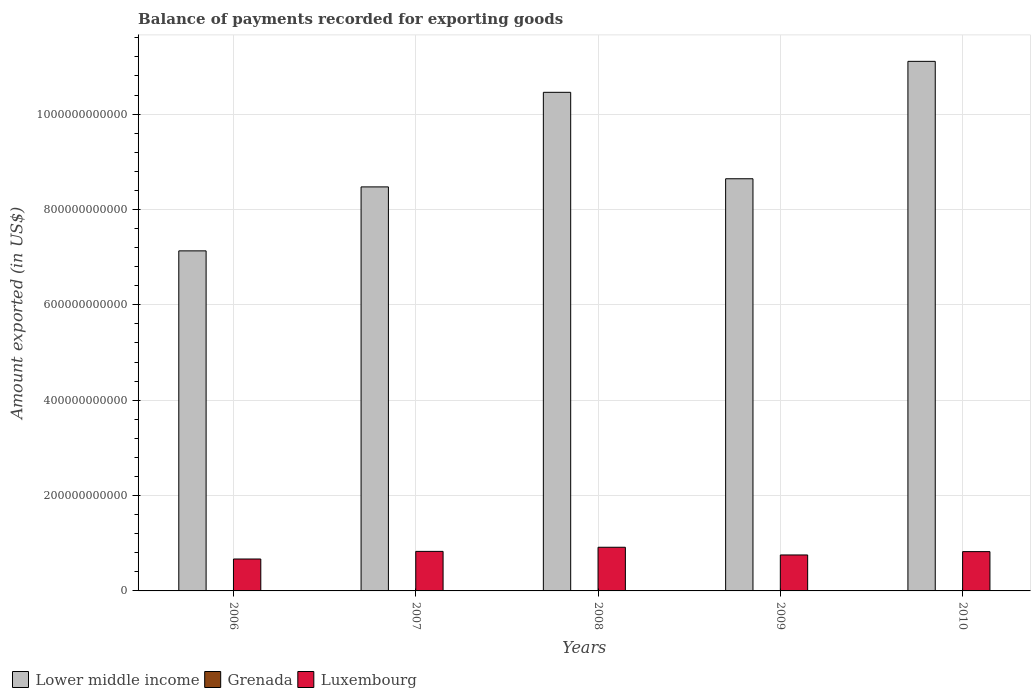How many different coloured bars are there?
Give a very brief answer. 3. How many groups of bars are there?
Make the answer very short. 5. Are the number of bars on each tick of the X-axis equal?
Provide a short and direct response. Yes. How many bars are there on the 4th tick from the right?
Your answer should be very brief. 3. What is the label of the 5th group of bars from the left?
Ensure brevity in your answer.  2010. What is the amount exported in Luxembourg in 2008?
Your answer should be very brief. 9.16e+1. Across all years, what is the maximum amount exported in Luxembourg?
Offer a very short reply. 9.16e+1. Across all years, what is the minimum amount exported in Lower middle income?
Provide a succinct answer. 7.13e+11. In which year was the amount exported in Luxembourg maximum?
Your response must be concise. 2008. In which year was the amount exported in Lower middle income minimum?
Make the answer very short. 2006. What is the total amount exported in Lower middle income in the graph?
Keep it short and to the point. 4.58e+12. What is the difference between the amount exported in Grenada in 2006 and that in 2007?
Your answer should be very brief. -4.72e+07. What is the difference between the amount exported in Luxembourg in 2008 and the amount exported in Lower middle income in 2010?
Your answer should be very brief. -1.02e+12. What is the average amount exported in Lower middle income per year?
Your answer should be very brief. 9.16e+11. In the year 2008, what is the difference between the amount exported in Lower middle income and amount exported in Luxembourg?
Keep it short and to the point. 9.54e+11. What is the ratio of the amount exported in Lower middle income in 2007 to that in 2010?
Ensure brevity in your answer.  0.76. What is the difference between the highest and the second highest amount exported in Grenada?
Your answer should be very brief. 1.75e+06. What is the difference between the highest and the lowest amount exported in Luxembourg?
Your answer should be very brief. 2.47e+1. Is the sum of the amount exported in Lower middle income in 2008 and 2009 greater than the maximum amount exported in Grenada across all years?
Provide a succinct answer. Yes. What does the 1st bar from the left in 2008 represents?
Provide a succinct answer. Lower middle income. What does the 2nd bar from the right in 2009 represents?
Provide a short and direct response. Grenada. Is it the case that in every year, the sum of the amount exported in Luxembourg and amount exported in Lower middle income is greater than the amount exported in Grenada?
Ensure brevity in your answer.  Yes. Are all the bars in the graph horizontal?
Provide a short and direct response. No. How many years are there in the graph?
Give a very brief answer. 5. What is the difference between two consecutive major ticks on the Y-axis?
Make the answer very short. 2.00e+11. Does the graph contain grids?
Make the answer very short. Yes. What is the title of the graph?
Your answer should be very brief. Balance of payments recorded for exporting goods. Does "Kiribati" appear as one of the legend labels in the graph?
Make the answer very short. No. What is the label or title of the X-axis?
Offer a very short reply. Years. What is the label or title of the Y-axis?
Your answer should be compact. Amount exported (in US$). What is the Amount exported (in US$) of Lower middle income in 2006?
Your answer should be compact. 7.13e+11. What is the Amount exported (in US$) of Grenada in 2006?
Your answer should be very brief. 1.62e+08. What is the Amount exported (in US$) in Luxembourg in 2006?
Ensure brevity in your answer.  6.69e+1. What is the Amount exported (in US$) in Lower middle income in 2007?
Offer a terse response. 8.47e+11. What is the Amount exported (in US$) of Grenada in 2007?
Give a very brief answer. 2.10e+08. What is the Amount exported (in US$) in Luxembourg in 2007?
Your answer should be very brief. 8.29e+1. What is the Amount exported (in US$) of Lower middle income in 2008?
Provide a succinct answer. 1.05e+12. What is the Amount exported (in US$) of Grenada in 2008?
Your answer should be very brief. 2.08e+08. What is the Amount exported (in US$) in Luxembourg in 2008?
Provide a succinct answer. 9.16e+1. What is the Amount exported (in US$) of Lower middle income in 2009?
Provide a short and direct response. 8.64e+11. What is the Amount exported (in US$) of Grenada in 2009?
Provide a succinct answer. 1.87e+08. What is the Amount exported (in US$) of Luxembourg in 2009?
Provide a short and direct response. 7.54e+1. What is the Amount exported (in US$) in Lower middle income in 2010?
Ensure brevity in your answer.  1.11e+12. What is the Amount exported (in US$) of Grenada in 2010?
Provide a short and direct response. 1.84e+08. What is the Amount exported (in US$) in Luxembourg in 2010?
Offer a very short reply. 8.24e+1. Across all years, what is the maximum Amount exported (in US$) in Lower middle income?
Offer a very short reply. 1.11e+12. Across all years, what is the maximum Amount exported (in US$) of Grenada?
Provide a short and direct response. 2.10e+08. Across all years, what is the maximum Amount exported (in US$) in Luxembourg?
Offer a terse response. 9.16e+1. Across all years, what is the minimum Amount exported (in US$) in Lower middle income?
Your answer should be compact. 7.13e+11. Across all years, what is the minimum Amount exported (in US$) in Grenada?
Your response must be concise. 1.62e+08. Across all years, what is the minimum Amount exported (in US$) of Luxembourg?
Your response must be concise. 6.69e+1. What is the total Amount exported (in US$) in Lower middle income in the graph?
Keep it short and to the point. 4.58e+12. What is the total Amount exported (in US$) of Grenada in the graph?
Your response must be concise. 9.51e+08. What is the total Amount exported (in US$) in Luxembourg in the graph?
Offer a terse response. 3.99e+11. What is the difference between the Amount exported (in US$) in Lower middle income in 2006 and that in 2007?
Keep it short and to the point. -1.34e+11. What is the difference between the Amount exported (in US$) of Grenada in 2006 and that in 2007?
Offer a terse response. -4.72e+07. What is the difference between the Amount exported (in US$) in Luxembourg in 2006 and that in 2007?
Your answer should be compact. -1.60e+1. What is the difference between the Amount exported (in US$) of Lower middle income in 2006 and that in 2008?
Provide a succinct answer. -3.33e+11. What is the difference between the Amount exported (in US$) of Grenada in 2006 and that in 2008?
Provide a short and direct response. -4.55e+07. What is the difference between the Amount exported (in US$) in Luxembourg in 2006 and that in 2008?
Your response must be concise. -2.47e+1. What is the difference between the Amount exported (in US$) in Lower middle income in 2006 and that in 2009?
Provide a short and direct response. -1.51e+11. What is the difference between the Amount exported (in US$) of Grenada in 2006 and that in 2009?
Provide a succinct answer. -2.49e+07. What is the difference between the Amount exported (in US$) of Luxembourg in 2006 and that in 2009?
Make the answer very short. -8.52e+09. What is the difference between the Amount exported (in US$) in Lower middle income in 2006 and that in 2010?
Give a very brief answer. -3.97e+11. What is the difference between the Amount exported (in US$) of Grenada in 2006 and that in 2010?
Provide a succinct answer. -2.15e+07. What is the difference between the Amount exported (in US$) of Luxembourg in 2006 and that in 2010?
Give a very brief answer. -1.55e+1. What is the difference between the Amount exported (in US$) of Lower middle income in 2007 and that in 2008?
Keep it short and to the point. -1.98e+11. What is the difference between the Amount exported (in US$) in Grenada in 2007 and that in 2008?
Offer a terse response. 1.75e+06. What is the difference between the Amount exported (in US$) in Luxembourg in 2007 and that in 2008?
Ensure brevity in your answer.  -8.66e+09. What is the difference between the Amount exported (in US$) of Lower middle income in 2007 and that in 2009?
Your answer should be compact. -1.71e+1. What is the difference between the Amount exported (in US$) in Grenada in 2007 and that in 2009?
Your answer should be compact. 2.23e+07. What is the difference between the Amount exported (in US$) in Luxembourg in 2007 and that in 2009?
Give a very brief answer. 7.48e+09. What is the difference between the Amount exported (in US$) of Lower middle income in 2007 and that in 2010?
Offer a very short reply. -2.63e+11. What is the difference between the Amount exported (in US$) of Grenada in 2007 and that in 2010?
Ensure brevity in your answer.  2.58e+07. What is the difference between the Amount exported (in US$) of Luxembourg in 2007 and that in 2010?
Ensure brevity in your answer.  4.69e+08. What is the difference between the Amount exported (in US$) in Lower middle income in 2008 and that in 2009?
Make the answer very short. 1.81e+11. What is the difference between the Amount exported (in US$) of Grenada in 2008 and that in 2009?
Provide a succinct answer. 2.06e+07. What is the difference between the Amount exported (in US$) in Luxembourg in 2008 and that in 2009?
Provide a succinct answer. 1.61e+1. What is the difference between the Amount exported (in US$) in Lower middle income in 2008 and that in 2010?
Give a very brief answer. -6.49e+1. What is the difference between the Amount exported (in US$) of Grenada in 2008 and that in 2010?
Make the answer very short. 2.40e+07. What is the difference between the Amount exported (in US$) of Luxembourg in 2008 and that in 2010?
Ensure brevity in your answer.  9.13e+09. What is the difference between the Amount exported (in US$) of Lower middle income in 2009 and that in 2010?
Keep it short and to the point. -2.46e+11. What is the difference between the Amount exported (in US$) in Grenada in 2009 and that in 2010?
Offer a terse response. 3.48e+06. What is the difference between the Amount exported (in US$) of Luxembourg in 2009 and that in 2010?
Ensure brevity in your answer.  -7.01e+09. What is the difference between the Amount exported (in US$) of Lower middle income in 2006 and the Amount exported (in US$) of Grenada in 2007?
Your response must be concise. 7.13e+11. What is the difference between the Amount exported (in US$) of Lower middle income in 2006 and the Amount exported (in US$) of Luxembourg in 2007?
Ensure brevity in your answer.  6.30e+11. What is the difference between the Amount exported (in US$) of Grenada in 2006 and the Amount exported (in US$) of Luxembourg in 2007?
Provide a short and direct response. -8.28e+1. What is the difference between the Amount exported (in US$) of Lower middle income in 2006 and the Amount exported (in US$) of Grenada in 2008?
Provide a short and direct response. 7.13e+11. What is the difference between the Amount exported (in US$) in Lower middle income in 2006 and the Amount exported (in US$) in Luxembourg in 2008?
Make the answer very short. 6.22e+11. What is the difference between the Amount exported (in US$) of Grenada in 2006 and the Amount exported (in US$) of Luxembourg in 2008?
Make the answer very short. -9.14e+1. What is the difference between the Amount exported (in US$) of Lower middle income in 2006 and the Amount exported (in US$) of Grenada in 2009?
Provide a short and direct response. 7.13e+11. What is the difference between the Amount exported (in US$) of Lower middle income in 2006 and the Amount exported (in US$) of Luxembourg in 2009?
Provide a succinct answer. 6.38e+11. What is the difference between the Amount exported (in US$) of Grenada in 2006 and the Amount exported (in US$) of Luxembourg in 2009?
Give a very brief answer. -7.53e+1. What is the difference between the Amount exported (in US$) in Lower middle income in 2006 and the Amount exported (in US$) in Grenada in 2010?
Your answer should be compact. 7.13e+11. What is the difference between the Amount exported (in US$) in Lower middle income in 2006 and the Amount exported (in US$) in Luxembourg in 2010?
Your answer should be compact. 6.31e+11. What is the difference between the Amount exported (in US$) in Grenada in 2006 and the Amount exported (in US$) in Luxembourg in 2010?
Provide a short and direct response. -8.23e+1. What is the difference between the Amount exported (in US$) in Lower middle income in 2007 and the Amount exported (in US$) in Grenada in 2008?
Keep it short and to the point. 8.47e+11. What is the difference between the Amount exported (in US$) of Lower middle income in 2007 and the Amount exported (in US$) of Luxembourg in 2008?
Ensure brevity in your answer.  7.56e+11. What is the difference between the Amount exported (in US$) of Grenada in 2007 and the Amount exported (in US$) of Luxembourg in 2008?
Keep it short and to the point. -9.14e+1. What is the difference between the Amount exported (in US$) of Lower middle income in 2007 and the Amount exported (in US$) of Grenada in 2009?
Your response must be concise. 8.47e+11. What is the difference between the Amount exported (in US$) in Lower middle income in 2007 and the Amount exported (in US$) in Luxembourg in 2009?
Offer a very short reply. 7.72e+11. What is the difference between the Amount exported (in US$) in Grenada in 2007 and the Amount exported (in US$) in Luxembourg in 2009?
Make the answer very short. -7.52e+1. What is the difference between the Amount exported (in US$) of Lower middle income in 2007 and the Amount exported (in US$) of Grenada in 2010?
Ensure brevity in your answer.  8.47e+11. What is the difference between the Amount exported (in US$) of Lower middle income in 2007 and the Amount exported (in US$) of Luxembourg in 2010?
Keep it short and to the point. 7.65e+11. What is the difference between the Amount exported (in US$) in Grenada in 2007 and the Amount exported (in US$) in Luxembourg in 2010?
Offer a terse response. -8.22e+1. What is the difference between the Amount exported (in US$) in Lower middle income in 2008 and the Amount exported (in US$) in Grenada in 2009?
Ensure brevity in your answer.  1.05e+12. What is the difference between the Amount exported (in US$) of Lower middle income in 2008 and the Amount exported (in US$) of Luxembourg in 2009?
Provide a short and direct response. 9.70e+11. What is the difference between the Amount exported (in US$) in Grenada in 2008 and the Amount exported (in US$) in Luxembourg in 2009?
Give a very brief answer. -7.52e+1. What is the difference between the Amount exported (in US$) in Lower middle income in 2008 and the Amount exported (in US$) in Grenada in 2010?
Your answer should be very brief. 1.05e+12. What is the difference between the Amount exported (in US$) of Lower middle income in 2008 and the Amount exported (in US$) of Luxembourg in 2010?
Make the answer very short. 9.63e+11. What is the difference between the Amount exported (in US$) in Grenada in 2008 and the Amount exported (in US$) in Luxembourg in 2010?
Keep it short and to the point. -8.22e+1. What is the difference between the Amount exported (in US$) in Lower middle income in 2009 and the Amount exported (in US$) in Grenada in 2010?
Provide a succinct answer. 8.64e+11. What is the difference between the Amount exported (in US$) of Lower middle income in 2009 and the Amount exported (in US$) of Luxembourg in 2010?
Ensure brevity in your answer.  7.82e+11. What is the difference between the Amount exported (in US$) in Grenada in 2009 and the Amount exported (in US$) in Luxembourg in 2010?
Give a very brief answer. -8.23e+1. What is the average Amount exported (in US$) of Lower middle income per year?
Your answer should be compact. 9.16e+11. What is the average Amount exported (in US$) of Grenada per year?
Ensure brevity in your answer.  1.90e+08. What is the average Amount exported (in US$) of Luxembourg per year?
Provide a short and direct response. 7.99e+1. In the year 2006, what is the difference between the Amount exported (in US$) of Lower middle income and Amount exported (in US$) of Grenada?
Your answer should be very brief. 7.13e+11. In the year 2006, what is the difference between the Amount exported (in US$) of Lower middle income and Amount exported (in US$) of Luxembourg?
Your response must be concise. 6.46e+11. In the year 2006, what is the difference between the Amount exported (in US$) in Grenada and Amount exported (in US$) in Luxembourg?
Your answer should be very brief. -6.68e+1. In the year 2007, what is the difference between the Amount exported (in US$) of Lower middle income and Amount exported (in US$) of Grenada?
Your response must be concise. 8.47e+11. In the year 2007, what is the difference between the Amount exported (in US$) in Lower middle income and Amount exported (in US$) in Luxembourg?
Make the answer very short. 7.64e+11. In the year 2007, what is the difference between the Amount exported (in US$) in Grenada and Amount exported (in US$) in Luxembourg?
Offer a very short reply. -8.27e+1. In the year 2008, what is the difference between the Amount exported (in US$) in Lower middle income and Amount exported (in US$) in Grenada?
Ensure brevity in your answer.  1.05e+12. In the year 2008, what is the difference between the Amount exported (in US$) of Lower middle income and Amount exported (in US$) of Luxembourg?
Provide a succinct answer. 9.54e+11. In the year 2008, what is the difference between the Amount exported (in US$) in Grenada and Amount exported (in US$) in Luxembourg?
Your answer should be compact. -9.14e+1. In the year 2009, what is the difference between the Amount exported (in US$) of Lower middle income and Amount exported (in US$) of Grenada?
Offer a terse response. 8.64e+11. In the year 2009, what is the difference between the Amount exported (in US$) in Lower middle income and Amount exported (in US$) in Luxembourg?
Offer a terse response. 7.89e+11. In the year 2009, what is the difference between the Amount exported (in US$) of Grenada and Amount exported (in US$) of Luxembourg?
Your answer should be very brief. -7.52e+1. In the year 2010, what is the difference between the Amount exported (in US$) of Lower middle income and Amount exported (in US$) of Grenada?
Offer a very short reply. 1.11e+12. In the year 2010, what is the difference between the Amount exported (in US$) of Lower middle income and Amount exported (in US$) of Luxembourg?
Your answer should be compact. 1.03e+12. In the year 2010, what is the difference between the Amount exported (in US$) in Grenada and Amount exported (in US$) in Luxembourg?
Provide a short and direct response. -8.23e+1. What is the ratio of the Amount exported (in US$) of Lower middle income in 2006 to that in 2007?
Your response must be concise. 0.84. What is the ratio of the Amount exported (in US$) of Grenada in 2006 to that in 2007?
Your answer should be very brief. 0.77. What is the ratio of the Amount exported (in US$) of Luxembourg in 2006 to that in 2007?
Give a very brief answer. 0.81. What is the ratio of the Amount exported (in US$) in Lower middle income in 2006 to that in 2008?
Provide a succinct answer. 0.68. What is the ratio of the Amount exported (in US$) of Grenada in 2006 to that in 2008?
Keep it short and to the point. 0.78. What is the ratio of the Amount exported (in US$) of Luxembourg in 2006 to that in 2008?
Offer a terse response. 0.73. What is the ratio of the Amount exported (in US$) of Lower middle income in 2006 to that in 2009?
Provide a succinct answer. 0.82. What is the ratio of the Amount exported (in US$) of Grenada in 2006 to that in 2009?
Your answer should be very brief. 0.87. What is the ratio of the Amount exported (in US$) of Luxembourg in 2006 to that in 2009?
Give a very brief answer. 0.89. What is the ratio of the Amount exported (in US$) of Lower middle income in 2006 to that in 2010?
Offer a very short reply. 0.64. What is the ratio of the Amount exported (in US$) in Grenada in 2006 to that in 2010?
Provide a succinct answer. 0.88. What is the ratio of the Amount exported (in US$) in Luxembourg in 2006 to that in 2010?
Ensure brevity in your answer.  0.81. What is the ratio of the Amount exported (in US$) in Lower middle income in 2007 to that in 2008?
Your response must be concise. 0.81. What is the ratio of the Amount exported (in US$) of Grenada in 2007 to that in 2008?
Your response must be concise. 1.01. What is the ratio of the Amount exported (in US$) in Luxembourg in 2007 to that in 2008?
Provide a short and direct response. 0.91. What is the ratio of the Amount exported (in US$) in Lower middle income in 2007 to that in 2009?
Offer a very short reply. 0.98. What is the ratio of the Amount exported (in US$) of Grenada in 2007 to that in 2009?
Your answer should be very brief. 1.12. What is the ratio of the Amount exported (in US$) in Luxembourg in 2007 to that in 2009?
Offer a terse response. 1.1. What is the ratio of the Amount exported (in US$) in Lower middle income in 2007 to that in 2010?
Provide a succinct answer. 0.76. What is the ratio of the Amount exported (in US$) of Grenada in 2007 to that in 2010?
Offer a terse response. 1.14. What is the ratio of the Amount exported (in US$) of Lower middle income in 2008 to that in 2009?
Provide a succinct answer. 1.21. What is the ratio of the Amount exported (in US$) of Grenada in 2008 to that in 2009?
Your answer should be compact. 1.11. What is the ratio of the Amount exported (in US$) of Luxembourg in 2008 to that in 2009?
Offer a terse response. 1.21. What is the ratio of the Amount exported (in US$) of Lower middle income in 2008 to that in 2010?
Give a very brief answer. 0.94. What is the ratio of the Amount exported (in US$) in Grenada in 2008 to that in 2010?
Your answer should be compact. 1.13. What is the ratio of the Amount exported (in US$) of Luxembourg in 2008 to that in 2010?
Make the answer very short. 1.11. What is the ratio of the Amount exported (in US$) in Lower middle income in 2009 to that in 2010?
Offer a very short reply. 0.78. What is the ratio of the Amount exported (in US$) in Grenada in 2009 to that in 2010?
Make the answer very short. 1.02. What is the ratio of the Amount exported (in US$) in Luxembourg in 2009 to that in 2010?
Ensure brevity in your answer.  0.92. What is the difference between the highest and the second highest Amount exported (in US$) in Lower middle income?
Ensure brevity in your answer.  6.49e+1. What is the difference between the highest and the second highest Amount exported (in US$) in Grenada?
Ensure brevity in your answer.  1.75e+06. What is the difference between the highest and the second highest Amount exported (in US$) in Luxembourg?
Your answer should be compact. 8.66e+09. What is the difference between the highest and the lowest Amount exported (in US$) of Lower middle income?
Offer a very short reply. 3.97e+11. What is the difference between the highest and the lowest Amount exported (in US$) in Grenada?
Give a very brief answer. 4.72e+07. What is the difference between the highest and the lowest Amount exported (in US$) in Luxembourg?
Offer a very short reply. 2.47e+1. 